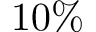Convert formula to latex. <formula><loc_0><loc_0><loc_500><loc_500>1 0 \%</formula> 